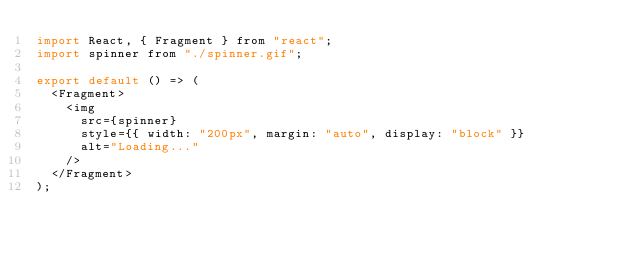<code> <loc_0><loc_0><loc_500><loc_500><_JavaScript_>import React, { Fragment } from "react";
import spinner from "./spinner.gif";

export default () => (
  <Fragment>
    <img
      src={spinner}
      style={{ width: "200px", margin: "auto", display: "block" }}
      alt="Loading..."
    />
  </Fragment>
);
</code> 